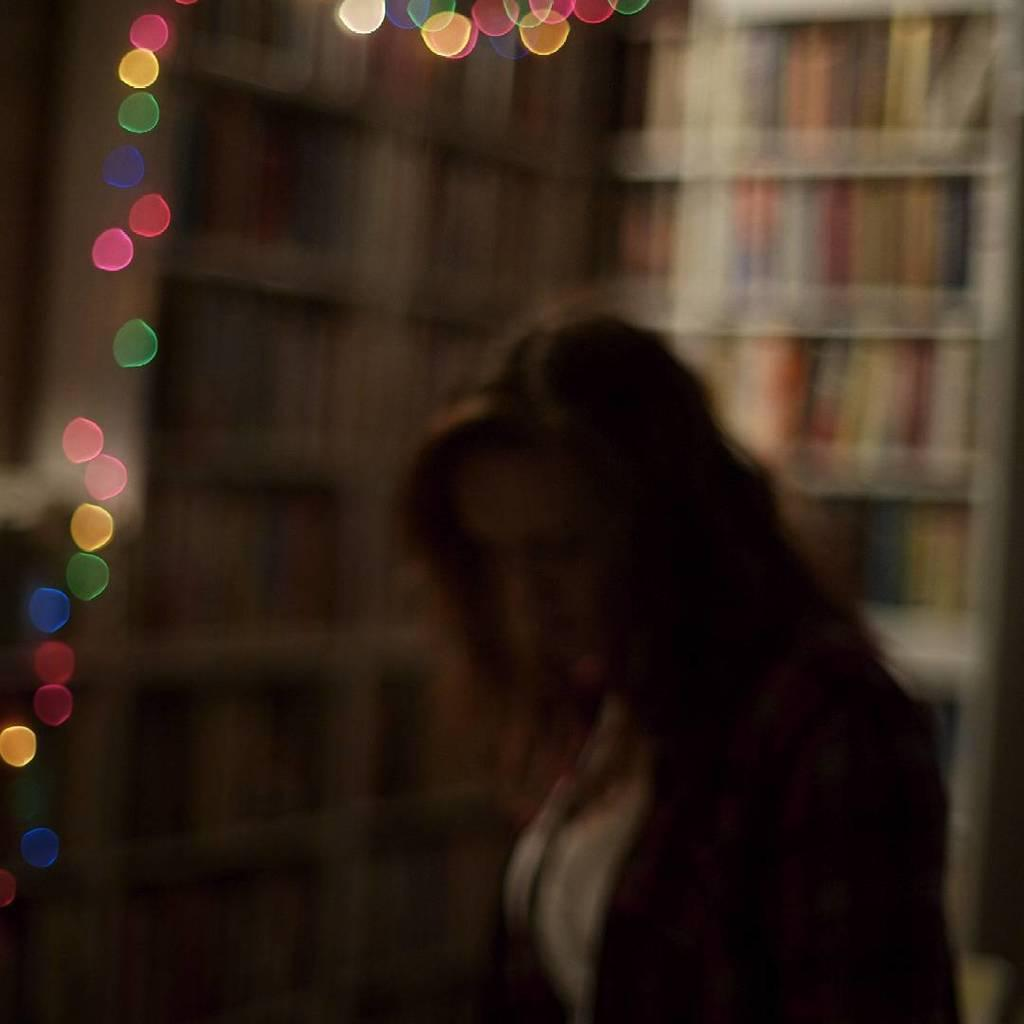Who is the main subject in the image? There is a lady in the image. What can be seen in the image besides the lady? There are many lights in the image. Can you describe the background of the image? The background of the image is blurred. What type of orange is the minister holding in the image? There is no minister or orange present in the image. Is there a hook visible in the image? There is no hook visible in the image. 